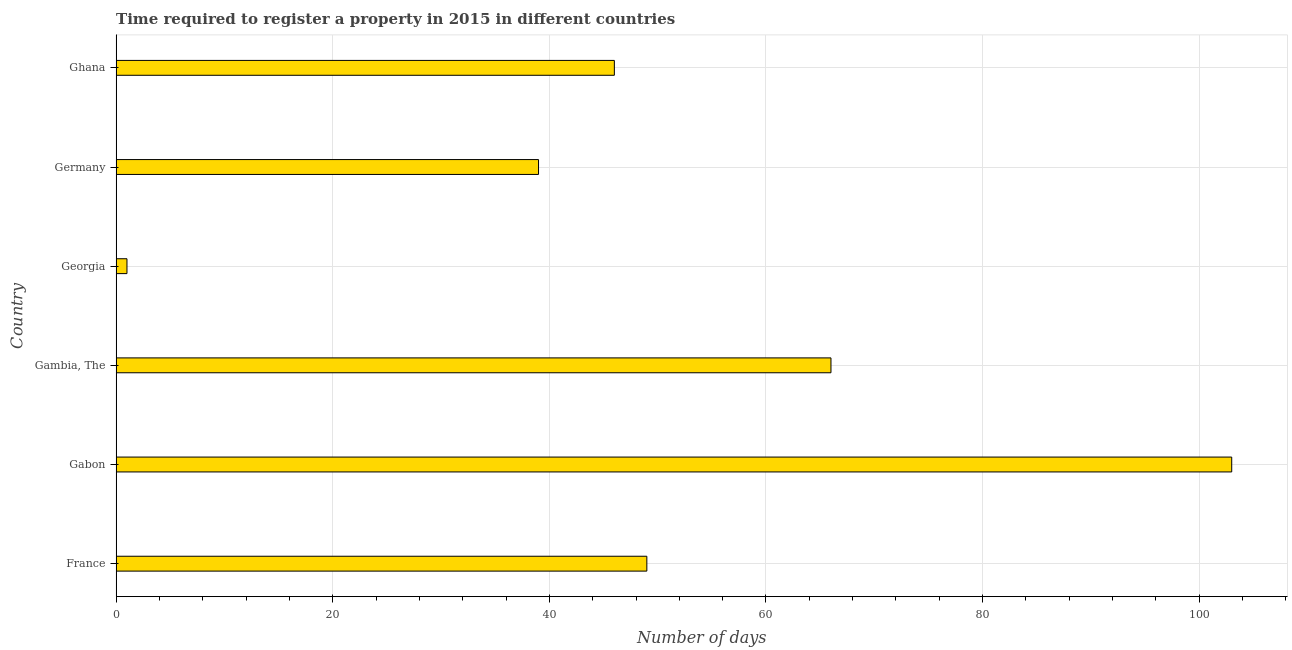Does the graph contain any zero values?
Keep it short and to the point. No. What is the title of the graph?
Your answer should be very brief. Time required to register a property in 2015 in different countries. What is the label or title of the X-axis?
Make the answer very short. Number of days. Across all countries, what is the maximum number of days required to register property?
Give a very brief answer. 103. Across all countries, what is the minimum number of days required to register property?
Offer a very short reply. 1. In which country was the number of days required to register property maximum?
Your answer should be very brief. Gabon. In which country was the number of days required to register property minimum?
Provide a short and direct response. Georgia. What is the sum of the number of days required to register property?
Give a very brief answer. 304. What is the difference between the number of days required to register property in France and Georgia?
Provide a succinct answer. 48. What is the average number of days required to register property per country?
Make the answer very short. 50.67. What is the median number of days required to register property?
Ensure brevity in your answer.  47.5. What is the ratio of the number of days required to register property in Gambia, The to that in Ghana?
Offer a terse response. 1.44. What is the difference between the highest and the lowest number of days required to register property?
Offer a very short reply. 102. Are the values on the major ticks of X-axis written in scientific E-notation?
Provide a succinct answer. No. What is the Number of days in France?
Give a very brief answer. 49. What is the Number of days in Gabon?
Provide a short and direct response. 103. What is the Number of days in Georgia?
Your answer should be compact. 1. What is the Number of days of Ghana?
Ensure brevity in your answer.  46. What is the difference between the Number of days in France and Gabon?
Your answer should be very brief. -54. What is the difference between the Number of days in France and Gambia, The?
Your answer should be very brief. -17. What is the difference between the Number of days in France and Georgia?
Provide a succinct answer. 48. What is the difference between the Number of days in Gabon and Georgia?
Give a very brief answer. 102. What is the difference between the Number of days in Gabon and Germany?
Provide a short and direct response. 64. What is the difference between the Number of days in Gambia, The and Georgia?
Ensure brevity in your answer.  65. What is the difference between the Number of days in Georgia and Germany?
Offer a very short reply. -38. What is the difference between the Number of days in Georgia and Ghana?
Offer a terse response. -45. What is the ratio of the Number of days in France to that in Gabon?
Offer a terse response. 0.48. What is the ratio of the Number of days in France to that in Gambia, The?
Provide a succinct answer. 0.74. What is the ratio of the Number of days in France to that in Germany?
Your response must be concise. 1.26. What is the ratio of the Number of days in France to that in Ghana?
Provide a succinct answer. 1.06. What is the ratio of the Number of days in Gabon to that in Gambia, The?
Your answer should be compact. 1.56. What is the ratio of the Number of days in Gabon to that in Georgia?
Your response must be concise. 103. What is the ratio of the Number of days in Gabon to that in Germany?
Offer a very short reply. 2.64. What is the ratio of the Number of days in Gabon to that in Ghana?
Provide a succinct answer. 2.24. What is the ratio of the Number of days in Gambia, The to that in Germany?
Your answer should be very brief. 1.69. What is the ratio of the Number of days in Gambia, The to that in Ghana?
Provide a succinct answer. 1.44. What is the ratio of the Number of days in Georgia to that in Germany?
Give a very brief answer. 0.03. What is the ratio of the Number of days in Georgia to that in Ghana?
Your response must be concise. 0.02. What is the ratio of the Number of days in Germany to that in Ghana?
Your answer should be compact. 0.85. 